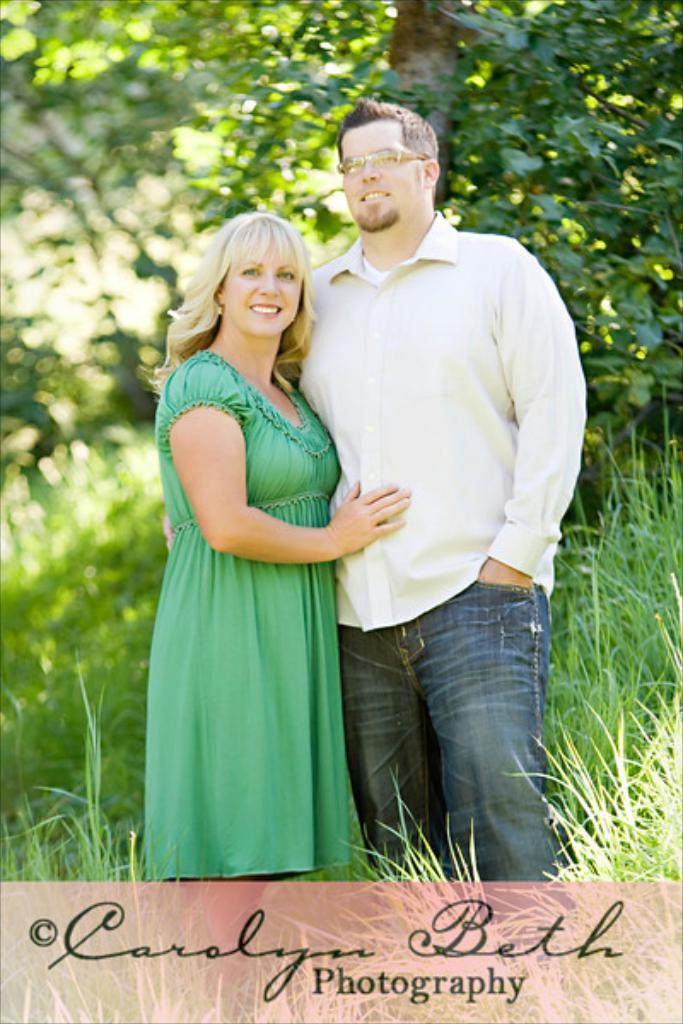Who can be seen in the image? There is a couple in the image. What is the couple's location in the image? The couple is standing in the grass. What can be seen in the background of the image? There are many trees behind the couple. What type of light can be seen illuminating the alley in the image? There is no alley or light present in the image; it features a couple standing in the grass with trees in the background. 